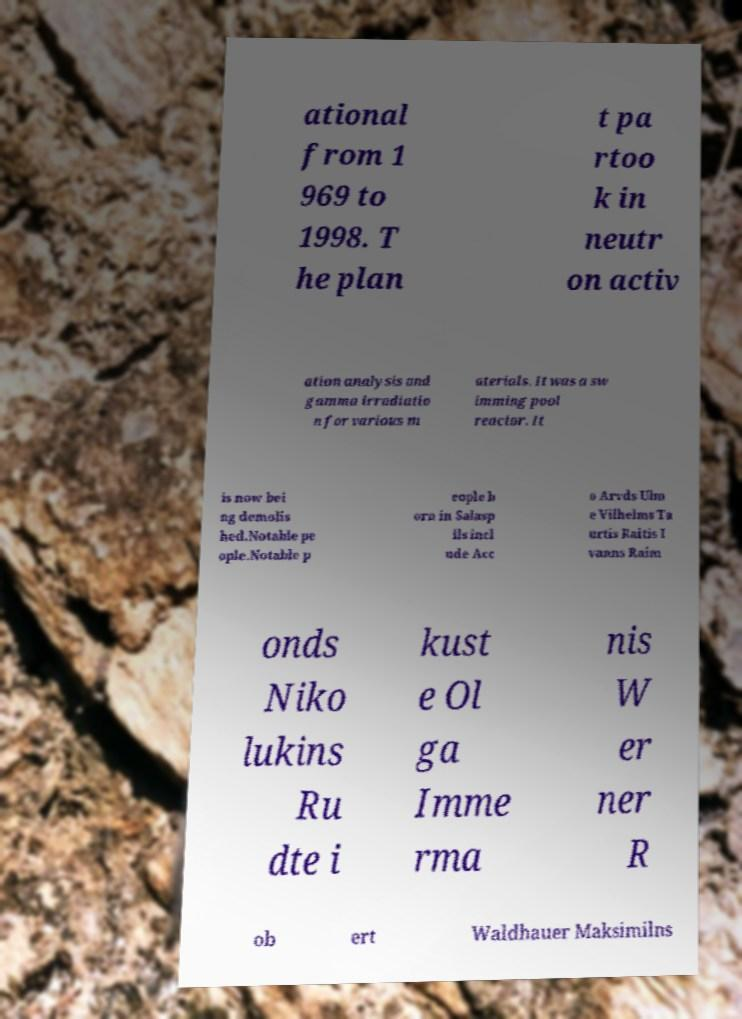What messages or text are displayed in this image? I need them in a readable, typed format. ational from 1 969 to 1998. T he plan t pa rtoo k in neutr on activ ation analysis and gamma irradiatio n for various m aterials. It was a sw imming pool reactor. It is now bei ng demolis hed.Notable pe ople.Notable p eople b orn in Salasp ils incl ude Acc o Arvds Ulm e Vilhelms Ta urtis Raitis I vanns Raim onds Niko lukins Ru dte i kust e Ol ga Imme rma nis W er ner R ob ert Waldhauer Maksimilns 